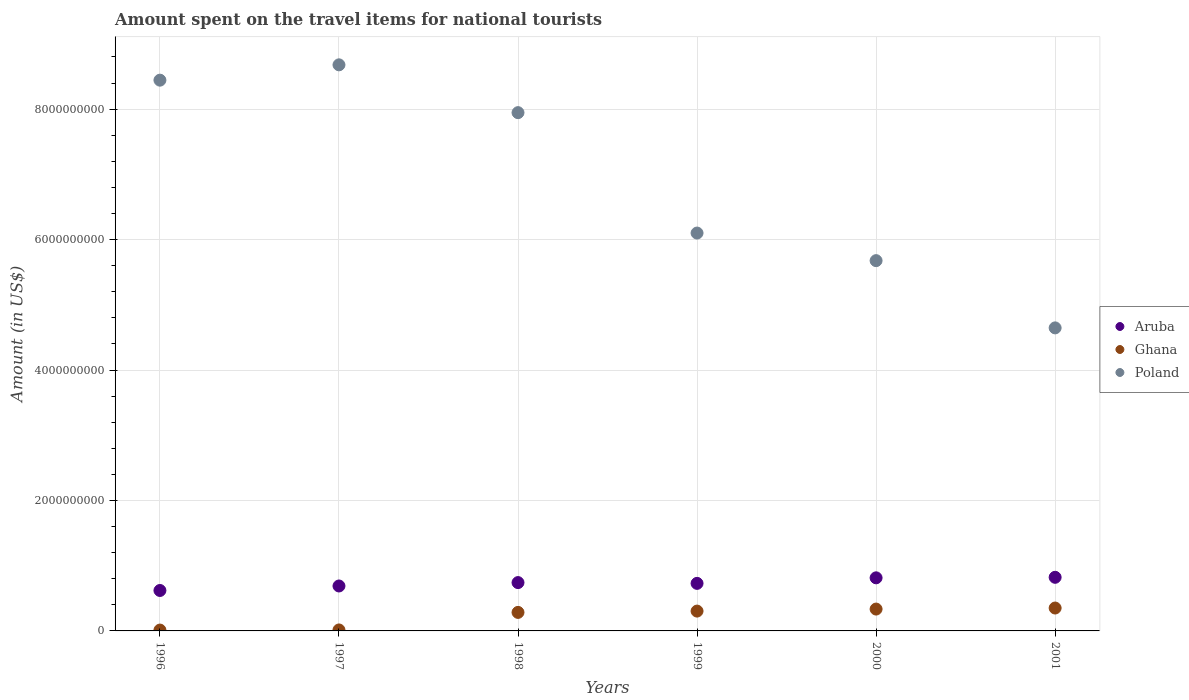How many different coloured dotlines are there?
Keep it short and to the point. 3. Is the number of dotlines equal to the number of legend labels?
Provide a short and direct response. Yes. What is the amount spent on the travel items for national tourists in Aruba in 2000?
Offer a very short reply. 8.14e+08. Across all years, what is the maximum amount spent on the travel items for national tourists in Aruba?
Offer a terse response. 8.22e+08. Across all years, what is the minimum amount spent on the travel items for national tourists in Poland?
Your answer should be compact. 4.65e+09. In which year was the amount spent on the travel items for national tourists in Aruba maximum?
Your answer should be compact. 2001. In which year was the amount spent on the travel items for national tourists in Ghana minimum?
Offer a very short reply. 1996. What is the total amount spent on the travel items for national tourists in Ghana in the graph?
Give a very brief answer. 1.30e+09. What is the difference between the amount spent on the travel items for national tourists in Poland in 1996 and that in 1999?
Provide a succinct answer. 2.34e+09. What is the difference between the amount spent on the travel items for national tourists in Poland in 1998 and the amount spent on the travel items for national tourists in Ghana in 2000?
Make the answer very short. 7.61e+09. What is the average amount spent on the travel items for national tourists in Aruba per year?
Your answer should be compact. 7.36e+08. In the year 2000, what is the difference between the amount spent on the travel items for national tourists in Aruba and amount spent on the travel items for national tourists in Ghana?
Offer a very short reply. 4.79e+08. In how many years, is the amount spent on the travel items for national tourists in Ghana greater than 6400000000 US$?
Your answer should be very brief. 0. What is the ratio of the amount spent on the travel items for national tourists in Ghana in 1998 to that in 1999?
Make the answer very short. 0.93. Is the amount spent on the travel items for national tourists in Ghana in 1997 less than that in 1999?
Provide a short and direct response. Yes. Is the difference between the amount spent on the travel items for national tourists in Aruba in 1998 and 2001 greater than the difference between the amount spent on the travel items for national tourists in Ghana in 1998 and 2001?
Keep it short and to the point. No. What is the difference between the highest and the second highest amount spent on the travel items for national tourists in Aruba?
Your answer should be very brief. 8.00e+06. What is the difference between the highest and the lowest amount spent on the travel items for national tourists in Poland?
Your response must be concise. 4.03e+09. Is the sum of the amount spent on the travel items for national tourists in Ghana in 1999 and 2001 greater than the maximum amount spent on the travel items for national tourists in Aruba across all years?
Give a very brief answer. No. Is the amount spent on the travel items for national tourists in Poland strictly greater than the amount spent on the travel items for national tourists in Aruba over the years?
Offer a terse response. Yes. Is the amount spent on the travel items for national tourists in Ghana strictly less than the amount spent on the travel items for national tourists in Poland over the years?
Your answer should be compact. Yes. How many dotlines are there?
Your response must be concise. 3. How many years are there in the graph?
Your answer should be compact. 6. Are the values on the major ticks of Y-axis written in scientific E-notation?
Your answer should be very brief. No. Where does the legend appear in the graph?
Give a very brief answer. Center right. How are the legend labels stacked?
Provide a succinct answer. Vertical. What is the title of the graph?
Provide a succinct answer. Amount spent on the travel items for national tourists. Does "Andorra" appear as one of the legend labels in the graph?
Offer a terse response. No. What is the label or title of the Y-axis?
Provide a succinct answer. Amount (in US$). What is the Amount (in US$) in Aruba in 1996?
Offer a very short reply. 6.20e+08. What is the Amount (in US$) of Ghana in 1996?
Make the answer very short. 1.30e+07. What is the Amount (in US$) in Poland in 1996?
Your answer should be compact. 8.44e+09. What is the Amount (in US$) in Aruba in 1997?
Your response must be concise. 6.89e+08. What is the Amount (in US$) in Ghana in 1997?
Ensure brevity in your answer.  1.50e+07. What is the Amount (in US$) of Poland in 1997?
Your response must be concise. 8.68e+09. What is the Amount (in US$) of Aruba in 1998?
Offer a terse response. 7.41e+08. What is the Amount (in US$) in Ghana in 1998?
Give a very brief answer. 2.84e+08. What is the Amount (in US$) of Poland in 1998?
Your answer should be very brief. 7.95e+09. What is the Amount (in US$) in Aruba in 1999?
Provide a short and direct response. 7.29e+08. What is the Amount (in US$) in Ghana in 1999?
Your answer should be very brief. 3.04e+08. What is the Amount (in US$) of Poland in 1999?
Give a very brief answer. 6.10e+09. What is the Amount (in US$) in Aruba in 2000?
Your answer should be very brief. 8.14e+08. What is the Amount (in US$) of Ghana in 2000?
Your answer should be very brief. 3.35e+08. What is the Amount (in US$) in Poland in 2000?
Keep it short and to the point. 5.68e+09. What is the Amount (in US$) of Aruba in 2001?
Give a very brief answer. 8.22e+08. What is the Amount (in US$) in Ghana in 2001?
Offer a terse response. 3.51e+08. What is the Amount (in US$) in Poland in 2001?
Your response must be concise. 4.65e+09. Across all years, what is the maximum Amount (in US$) in Aruba?
Your response must be concise. 8.22e+08. Across all years, what is the maximum Amount (in US$) of Ghana?
Your answer should be very brief. 3.51e+08. Across all years, what is the maximum Amount (in US$) in Poland?
Your answer should be compact. 8.68e+09. Across all years, what is the minimum Amount (in US$) in Aruba?
Your answer should be compact. 6.20e+08. Across all years, what is the minimum Amount (in US$) of Ghana?
Provide a succinct answer. 1.30e+07. Across all years, what is the minimum Amount (in US$) in Poland?
Your answer should be compact. 4.65e+09. What is the total Amount (in US$) of Aruba in the graph?
Make the answer very short. 4.42e+09. What is the total Amount (in US$) in Ghana in the graph?
Provide a succinct answer. 1.30e+09. What is the total Amount (in US$) in Poland in the graph?
Provide a succinct answer. 4.15e+1. What is the difference between the Amount (in US$) in Aruba in 1996 and that in 1997?
Offer a very short reply. -6.90e+07. What is the difference between the Amount (in US$) of Poland in 1996 and that in 1997?
Keep it short and to the point. -2.35e+08. What is the difference between the Amount (in US$) in Aruba in 1996 and that in 1998?
Ensure brevity in your answer.  -1.21e+08. What is the difference between the Amount (in US$) in Ghana in 1996 and that in 1998?
Your response must be concise. -2.71e+08. What is the difference between the Amount (in US$) of Poland in 1996 and that in 1998?
Provide a succinct answer. 4.98e+08. What is the difference between the Amount (in US$) in Aruba in 1996 and that in 1999?
Provide a short and direct response. -1.09e+08. What is the difference between the Amount (in US$) of Ghana in 1996 and that in 1999?
Your answer should be compact. -2.91e+08. What is the difference between the Amount (in US$) of Poland in 1996 and that in 1999?
Offer a very short reply. 2.34e+09. What is the difference between the Amount (in US$) in Aruba in 1996 and that in 2000?
Your answer should be very brief. -1.94e+08. What is the difference between the Amount (in US$) in Ghana in 1996 and that in 2000?
Offer a terse response. -3.22e+08. What is the difference between the Amount (in US$) of Poland in 1996 and that in 2000?
Your response must be concise. 2.77e+09. What is the difference between the Amount (in US$) of Aruba in 1996 and that in 2001?
Your answer should be very brief. -2.02e+08. What is the difference between the Amount (in US$) of Ghana in 1996 and that in 2001?
Offer a terse response. -3.38e+08. What is the difference between the Amount (in US$) of Poland in 1996 and that in 2001?
Provide a short and direct response. 3.80e+09. What is the difference between the Amount (in US$) of Aruba in 1997 and that in 1998?
Keep it short and to the point. -5.20e+07. What is the difference between the Amount (in US$) in Ghana in 1997 and that in 1998?
Your answer should be compact. -2.69e+08. What is the difference between the Amount (in US$) of Poland in 1997 and that in 1998?
Provide a succinct answer. 7.33e+08. What is the difference between the Amount (in US$) of Aruba in 1997 and that in 1999?
Ensure brevity in your answer.  -4.00e+07. What is the difference between the Amount (in US$) in Ghana in 1997 and that in 1999?
Ensure brevity in your answer.  -2.89e+08. What is the difference between the Amount (in US$) of Poland in 1997 and that in 1999?
Offer a very short reply. 2.58e+09. What is the difference between the Amount (in US$) in Aruba in 1997 and that in 2000?
Provide a succinct answer. -1.25e+08. What is the difference between the Amount (in US$) in Ghana in 1997 and that in 2000?
Offer a terse response. -3.20e+08. What is the difference between the Amount (in US$) in Poland in 1997 and that in 2000?
Your answer should be compact. 3.00e+09. What is the difference between the Amount (in US$) in Aruba in 1997 and that in 2001?
Your response must be concise. -1.33e+08. What is the difference between the Amount (in US$) of Ghana in 1997 and that in 2001?
Keep it short and to the point. -3.36e+08. What is the difference between the Amount (in US$) of Poland in 1997 and that in 2001?
Your answer should be very brief. 4.03e+09. What is the difference between the Amount (in US$) in Aruba in 1998 and that in 1999?
Offer a terse response. 1.20e+07. What is the difference between the Amount (in US$) in Ghana in 1998 and that in 1999?
Offer a very short reply. -2.00e+07. What is the difference between the Amount (in US$) of Poland in 1998 and that in 1999?
Your answer should be very brief. 1.85e+09. What is the difference between the Amount (in US$) of Aruba in 1998 and that in 2000?
Offer a terse response. -7.30e+07. What is the difference between the Amount (in US$) in Ghana in 1998 and that in 2000?
Ensure brevity in your answer.  -5.10e+07. What is the difference between the Amount (in US$) in Poland in 1998 and that in 2000?
Offer a very short reply. 2.27e+09. What is the difference between the Amount (in US$) in Aruba in 1998 and that in 2001?
Your response must be concise. -8.10e+07. What is the difference between the Amount (in US$) in Ghana in 1998 and that in 2001?
Your answer should be very brief. -6.70e+07. What is the difference between the Amount (in US$) in Poland in 1998 and that in 2001?
Give a very brief answer. 3.30e+09. What is the difference between the Amount (in US$) of Aruba in 1999 and that in 2000?
Make the answer very short. -8.50e+07. What is the difference between the Amount (in US$) of Ghana in 1999 and that in 2000?
Your answer should be very brief. -3.10e+07. What is the difference between the Amount (in US$) of Poland in 1999 and that in 2000?
Provide a succinct answer. 4.23e+08. What is the difference between the Amount (in US$) in Aruba in 1999 and that in 2001?
Your answer should be very brief. -9.30e+07. What is the difference between the Amount (in US$) in Ghana in 1999 and that in 2001?
Make the answer very short. -4.70e+07. What is the difference between the Amount (in US$) of Poland in 1999 and that in 2001?
Offer a terse response. 1.45e+09. What is the difference between the Amount (in US$) of Aruba in 2000 and that in 2001?
Provide a succinct answer. -8.00e+06. What is the difference between the Amount (in US$) of Ghana in 2000 and that in 2001?
Offer a terse response. -1.60e+07. What is the difference between the Amount (in US$) of Poland in 2000 and that in 2001?
Offer a terse response. 1.03e+09. What is the difference between the Amount (in US$) of Aruba in 1996 and the Amount (in US$) of Ghana in 1997?
Offer a terse response. 6.05e+08. What is the difference between the Amount (in US$) of Aruba in 1996 and the Amount (in US$) of Poland in 1997?
Provide a short and direct response. -8.06e+09. What is the difference between the Amount (in US$) of Ghana in 1996 and the Amount (in US$) of Poland in 1997?
Offer a very short reply. -8.67e+09. What is the difference between the Amount (in US$) in Aruba in 1996 and the Amount (in US$) in Ghana in 1998?
Provide a succinct answer. 3.36e+08. What is the difference between the Amount (in US$) of Aruba in 1996 and the Amount (in US$) of Poland in 1998?
Provide a succinct answer. -7.33e+09. What is the difference between the Amount (in US$) in Ghana in 1996 and the Amount (in US$) in Poland in 1998?
Provide a succinct answer. -7.93e+09. What is the difference between the Amount (in US$) of Aruba in 1996 and the Amount (in US$) of Ghana in 1999?
Ensure brevity in your answer.  3.16e+08. What is the difference between the Amount (in US$) in Aruba in 1996 and the Amount (in US$) in Poland in 1999?
Ensure brevity in your answer.  -5.48e+09. What is the difference between the Amount (in US$) in Ghana in 1996 and the Amount (in US$) in Poland in 1999?
Your answer should be compact. -6.09e+09. What is the difference between the Amount (in US$) of Aruba in 1996 and the Amount (in US$) of Ghana in 2000?
Your answer should be very brief. 2.85e+08. What is the difference between the Amount (in US$) in Aruba in 1996 and the Amount (in US$) in Poland in 2000?
Offer a very short reply. -5.06e+09. What is the difference between the Amount (in US$) in Ghana in 1996 and the Amount (in US$) in Poland in 2000?
Offer a terse response. -5.66e+09. What is the difference between the Amount (in US$) of Aruba in 1996 and the Amount (in US$) of Ghana in 2001?
Your response must be concise. 2.69e+08. What is the difference between the Amount (in US$) in Aruba in 1996 and the Amount (in US$) in Poland in 2001?
Make the answer very short. -4.03e+09. What is the difference between the Amount (in US$) of Ghana in 1996 and the Amount (in US$) of Poland in 2001?
Provide a succinct answer. -4.63e+09. What is the difference between the Amount (in US$) of Aruba in 1997 and the Amount (in US$) of Ghana in 1998?
Ensure brevity in your answer.  4.05e+08. What is the difference between the Amount (in US$) in Aruba in 1997 and the Amount (in US$) in Poland in 1998?
Your answer should be compact. -7.26e+09. What is the difference between the Amount (in US$) of Ghana in 1997 and the Amount (in US$) of Poland in 1998?
Offer a very short reply. -7.93e+09. What is the difference between the Amount (in US$) of Aruba in 1997 and the Amount (in US$) of Ghana in 1999?
Your response must be concise. 3.85e+08. What is the difference between the Amount (in US$) of Aruba in 1997 and the Amount (in US$) of Poland in 1999?
Your answer should be compact. -5.41e+09. What is the difference between the Amount (in US$) of Ghana in 1997 and the Amount (in US$) of Poland in 1999?
Your response must be concise. -6.08e+09. What is the difference between the Amount (in US$) of Aruba in 1997 and the Amount (in US$) of Ghana in 2000?
Give a very brief answer. 3.54e+08. What is the difference between the Amount (in US$) in Aruba in 1997 and the Amount (in US$) in Poland in 2000?
Your answer should be very brief. -4.99e+09. What is the difference between the Amount (in US$) of Ghana in 1997 and the Amount (in US$) of Poland in 2000?
Offer a terse response. -5.66e+09. What is the difference between the Amount (in US$) of Aruba in 1997 and the Amount (in US$) of Ghana in 2001?
Offer a terse response. 3.38e+08. What is the difference between the Amount (in US$) of Aruba in 1997 and the Amount (in US$) of Poland in 2001?
Your answer should be compact. -3.96e+09. What is the difference between the Amount (in US$) of Ghana in 1997 and the Amount (in US$) of Poland in 2001?
Give a very brief answer. -4.63e+09. What is the difference between the Amount (in US$) of Aruba in 1998 and the Amount (in US$) of Ghana in 1999?
Keep it short and to the point. 4.37e+08. What is the difference between the Amount (in US$) of Aruba in 1998 and the Amount (in US$) of Poland in 1999?
Offer a terse response. -5.36e+09. What is the difference between the Amount (in US$) in Ghana in 1998 and the Amount (in US$) in Poland in 1999?
Make the answer very short. -5.82e+09. What is the difference between the Amount (in US$) of Aruba in 1998 and the Amount (in US$) of Ghana in 2000?
Give a very brief answer. 4.06e+08. What is the difference between the Amount (in US$) in Aruba in 1998 and the Amount (in US$) in Poland in 2000?
Give a very brief answer. -4.94e+09. What is the difference between the Amount (in US$) in Ghana in 1998 and the Amount (in US$) in Poland in 2000?
Your answer should be very brief. -5.39e+09. What is the difference between the Amount (in US$) in Aruba in 1998 and the Amount (in US$) in Ghana in 2001?
Offer a very short reply. 3.90e+08. What is the difference between the Amount (in US$) of Aruba in 1998 and the Amount (in US$) of Poland in 2001?
Your answer should be compact. -3.90e+09. What is the difference between the Amount (in US$) in Ghana in 1998 and the Amount (in US$) in Poland in 2001?
Provide a short and direct response. -4.36e+09. What is the difference between the Amount (in US$) of Aruba in 1999 and the Amount (in US$) of Ghana in 2000?
Your answer should be very brief. 3.94e+08. What is the difference between the Amount (in US$) of Aruba in 1999 and the Amount (in US$) of Poland in 2000?
Provide a succinct answer. -4.95e+09. What is the difference between the Amount (in US$) in Ghana in 1999 and the Amount (in US$) in Poland in 2000?
Offer a very short reply. -5.37e+09. What is the difference between the Amount (in US$) of Aruba in 1999 and the Amount (in US$) of Ghana in 2001?
Your response must be concise. 3.78e+08. What is the difference between the Amount (in US$) of Aruba in 1999 and the Amount (in US$) of Poland in 2001?
Offer a very short reply. -3.92e+09. What is the difference between the Amount (in US$) in Ghana in 1999 and the Amount (in US$) in Poland in 2001?
Your answer should be very brief. -4.34e+09. What is the difference between the Amount (in US$) in Aruba in 2000 and the Amount (in US$) in Ghana in 2001?
Give a very brief answer. 4.63e+08. What is the difference between the Amount (in US$) in Aruba in 2000 and the Amount (in US$) in Poland in 2001?
Offer a very short reply. -3.83e+09. What is the difference between the Amount (in US$) of Ghana in 2000 and the Amount (in US$) of Poland in 2001?
Your answer should be compact. -4.31e+09. What is the average Amount (in US$) in Aruba per year?
Offer a terse response. 7.36e+08. What is the average Amount (in US$) of Ghana per year?
Make the answer very short. 2.17e+08. What is the average Amount (in US$) in Poland per year?
Your answer should be compact. 6.92e+09. In the year 1996, what is the difference between the Amount (in US$) in Aruba and Amount (in US$) in Ghana?
Ensure brevity in your answer.  6.07e+08. In the year 1996, what is the difference between the Amount (in US$) in Aruba and Amount (in US$) in Poland?
Your answer should be very brief. -7.82e+09. In the year 1996, what is the difference between the Amount (in US$) in Ghana and Amount (in US$) in Poland?
Provide a short and direct response. -8.43e+09. In the year 1997, what is the difference between the Amount (in US$) in Aruba and Amount (in US$) in Ghana?
Your answer should be very brief. 6.74e+08. In the year 1997, what is the difference between the Amount (in US$) in Aruba and Amount (in US$) in Poland?
Provide a succinct answer. -7.99e+09. In the year 1997, what is the difference between the Amount (in US$) of Ghana and Amount (in US$) of Poland?
Your response must be concise. -8.66e+09. In the year 1998, what is the difference between the Amount (in US$) of Aruba and Amount (in US$) of Ghana?
Your response must be concise. 4.57e+08. In the year 1998, what is the difference between the Amount (in US$) of Aruba and Amount (in US$) of Poland?
Offer a very short reply. -7.20e+09. In the year 1998, what is the difference between the Amount (in US$) of Ghana and Amount (in US$) of Poland?
Provide a short and direct response. -7.66e+09. In the year 1999, what is the difference between the Amount (in US$) of Aruba and Amount (in US$) of Ghana?
Offer a terse response. 4.25e+08. In the year 1999, what is the difference between the Amount (in US$) of Aruba and Amount (in US$) of Poland?
Provide a short and direct response. -5.37e+09. In the year 1999, what is the difference between the Amount (in US$) in Ghana and Amount (in US$) in Poland?
Your answer should be compact. -5.80e+09. In the year 2000, what is the difference between the Amount (in US$) of Aruba and Amount (in US$) of Ghana?
Keep it short and to the point. 4.79e+08. In the year 2000, what is the difference between the Amount (in US$) of Aruba and Amount (in US$) of Poland?
Make the answer very short. -4.86e+09. In the year 2000, what is the difference between the Amount (in US$) in Ghana and Amount (in US$) in Poland?
Give a very brief answer. -5.34e+09. In the year 2001, what is the difference between the Amount (in US$) in Aruba and Amount (in US$) in Ghana?
Make the answer very short. 4.71e+08. In the year 2001, what is the difference between the Amount (in US$) of Aruba and Amount (in US$) of Poland?
Offer a terse response. -3.82e+09. In the year 2001, what is the difference between the Amount (in US$) in Ghana and Amount (in US$) in Poland?
Give a very brief answer. -4.30e+09. What is the ratio of the Amount (in US$) of Aruba in 1996 to that in 1997?
Give a very brief answer. 0.9. What is the ratio of the Amount (in US$) of Ghana in 1996 to that in 1997?
Your answer should be compact. 0.87. What is the ratio of the Amount (in US$) in Poland in 1996 to that in 1997?
Make the answer very short. 0.97. What is the ratio of the Amount (in US$) of Aruba in 1996 to that in 1998?
Give a very brief answer. 0.84. What is the ratio of the Amount (in US$) of Ghana in 1996 to that in 1998?
Offer a terse response. 0.05. What is the ratio of the Amount (in US$) in Poland in 1996 to that in 1998?
Your answer should be very brief. 1.06. What is the ratio of the Amount (in US$) in Aruba in 1996 to that in 1999?
Give a very brief answer. 0.85. What is the ratio of the Amount (in US$) in Ghana in 1996 to that in 1999?
Your answer should be very brief. 0.04. What is the ratio of the Amount (in US$) of Poland in 1996 to that in 1999?
Offer a very short reply. 1.38. What is the ratio of the Amount (in US$) of Aruba in 1996 to that in 2000?
Your answer should be compact. 0.76. What is the ratio of the Amount (in US$) in Ghana in 1996 to that in 2000?
Offer a terse response. 0.04. What is the ratio of the Amount (in US$) of Poland in 1996 to that in 2000?
Your answer should be very brief. 1.49. What is the ratio of the Amount (in US$) of Aruba in 1996 to that in 2001?
Your answer should be very brief. 0.75. What is the ratio of the Amount (in US$) in Ghana in 1996 to that in 2001?
Ensure brevity in your answer.  0.04. What is the ratio of the Amount (in US$) of Poland in 1996 to that in 2001?
Keep it short and to the point. 1.82. What is the ratio of the Amount (in US$) of Aruba in 1997 to that in 1998?
Provide a short and direct response. 0.93. What is the ratio of the Amount (in US$) of Ghana in 1997 to that in 1998?
Provide a succinct answer. 0.05. What is the ratio of the Amount (in US$) in Poland in 1997 to that in 1998?
Your answer should be compact. 1.09. What is the ratio of the Amount (in US$) in Aruba in 1997 to that in 1999?
Keep it short and to the point. 0.95. What is the ratio of the Amount (in US$) of Ghana in 1997 to that in 1999?
Ensure brevity in your answer.  0.05. What is the ratio of the Amount (in US$) in Poland in 1997 to that in 1999?
Offer a terse response. 1.42. What is the ratio of the Amount (in US$) of Aruba in 1997 to that in 2000?
Offer a very short reply. 0.85. What is the ratio of the Amount (in US$) in Ghana in 1997 to that in 2000?
Make the answer very short. 0.04. What is the ratio of the Amount (in US$) in Poland in 1997 to that in 2000?
Provide a succinct answer. 1.53. What is the ratio of the Amount (in US$) in Aruba in 1997 to that in 2001?
Make the answer very short. 0.84. What is the ratio of the Amount (in US$) in Ghana in 1997 to that in 2001?
Offer a terse response. 0.04. What is the ratio of the Amount (in US$) of Poland in 1997 to that in 2001?
Make the answer very short. 1.87. What is the ratio of the Amount (in US$) of Aruba in 1998 to that in 1999?
Your answer should be compact. 1.02. What is the ratio of the Amount (in US$) in Ghana in 1998 to that in 1999?
Make the answer very short. 0.93. What is the ratio of the Amount (in US$) in Poland in 1998 to that in 1999?
Your answer should be very brief. 1.3. What is the ratio of the Amount (in US$) of Aruba in 1998 to that in 2000?
Offer a terse response. 0.91. What is the ratio of the Amount (in US$) in Ghana in 1998 to that in 2000?
Your response must be concise. 0.85. What is the ratio of the Amount (in US$) of Poland in 1998 to that in 2000?
Provide a succinct answer. 1.4. What is the ratio of the Amount (in US$) in Aruba in 1998 to that in 2001?
Your answer should be compact. 0.9. What is the ratio of the Amount (in US$) in Ghana in 1998 to that in 2001?
Your answer should be compact. 0.81. What is the ratio of the Amount (in US$) in Poland in 1998 to that in 2001?
Ensure brevity in your answer.  1.71. What is the ratio of the Amount (in US$) in Aruba in 1999 to that in 2000?
Your answer should be compact. 0.9. What is the ratio of the Amount (in US$) in Ghana in 1999 to that in 2000?
Ensure brevity in your answer.  0.91. What is the ratio of the Amount (in US$) of Poland in 1999 to that in 2000?
Provide a succinct answer. 1.07. What is the ratio of the Amount (in US$) of Aruba in 1999 to that in 2001?
Ensure brevity in your answer.  0.89. What is the ratio of the Amount (in US$) in Ghana in 1999 to that in 2001?
Your response must be concise. 0.87. What is the ratio of the Amount (in US$) of Poland in 1999 to that in 2001?
Offer a terse response. 1.31. What is the ratio of the Amount (in US$) in Aruba in 2000 to that in 2001?
Offer a terse response. 0.99. What is the ratio of the Amount (in US$) of Ghana in 2000 to that in 2001?
Your answer should be very brief. 0.95. What is the ratio of the Amount (in US$) in Poland in 2000 to that in 2001?
Provide a succinct answer. 1.22. What is the difference between the highest and the second highest Amount (in US$) in Ghana?
Provide a succinct answer. 1.60e+07. What is the difference between the highest and the second highest Amount (in US$) in Poland?
Your answer should be very brief. 2.35e+08. What is the difference between the highest and the lowest Amount (in US$) in Aruba?
Your answer should be very brief. 2.02e+08. What is the difference between the highest and the lowest Amount (in US$) of Ghana?
Your answer should be compact. 3.38e+08. What is the difference between the highest and the lowest Amount (in US$) in Poland?
Give a very brief answer. 4.03e+09. 